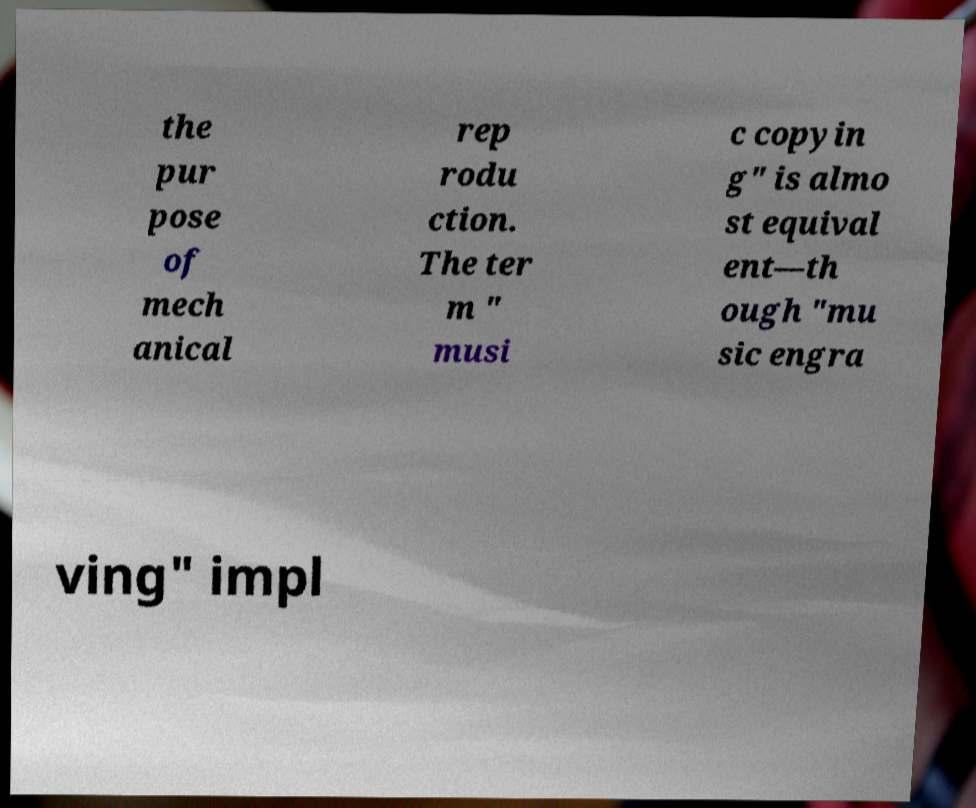There's text embedded in this image that I need extracted. Can you transcribe it verbatim? the pur pose of mech anical rep rodu ction. The ter m " musi c copyin g" is almo st equival ent—th ough "mu sic engra ving" impl 